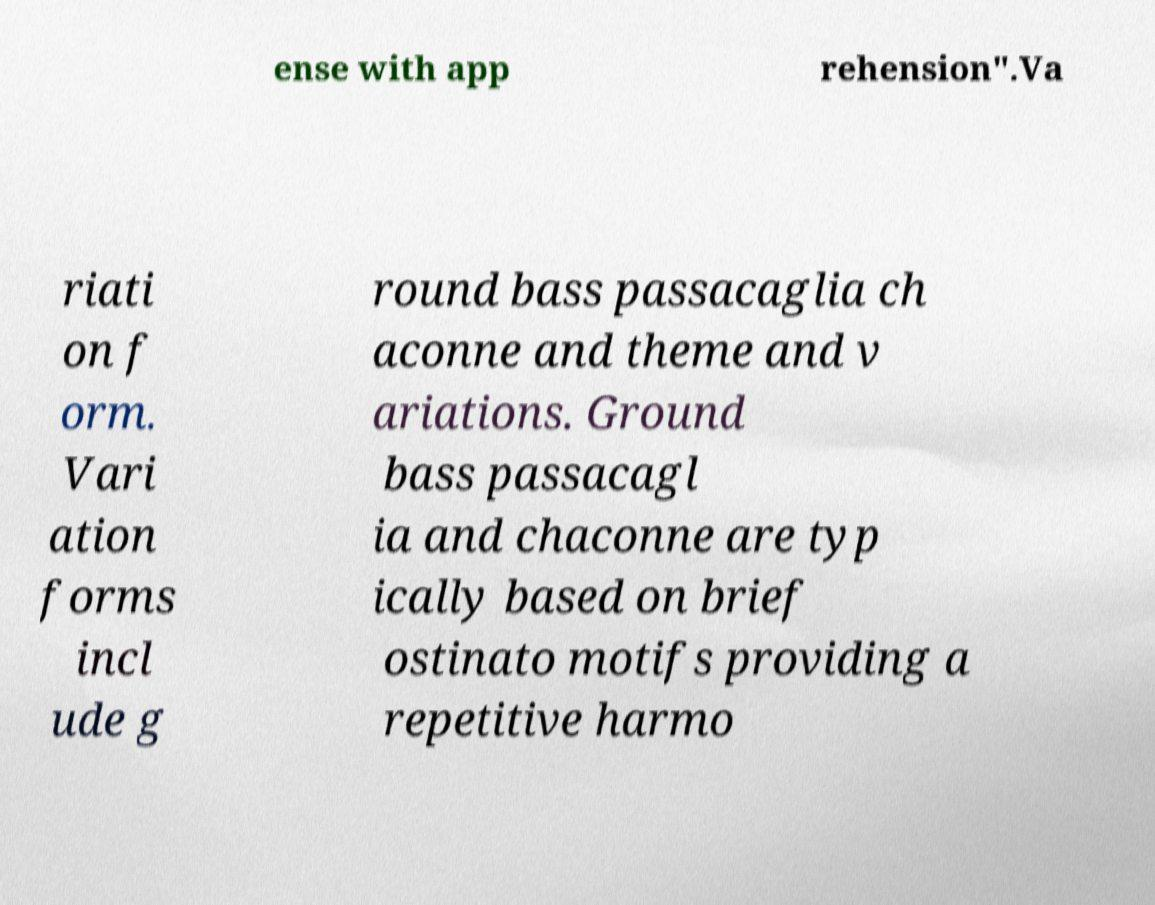Can you accurately transcribe the text from the provided image for me? ense with app rehension".Va riati on f orm. Vari ation forms incl ude g round bass passacaglia ch aconne and theme and v ariations. Ground bass passacagl ia and chaconne are typ ically based on brief ostinato motifs providing a repetitive harmo 